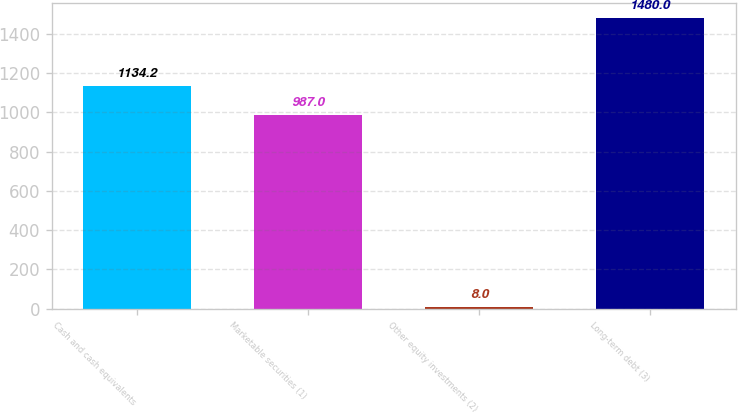<chart> <loc_0><loc_0><loc_500><loc_500><bar_chart><fcel>Cash and cash equivalents<fcel>Marketable securities (1)<fcel>Other equity investments (2)<fcel>Long-term debt (3)<nl><fcel>1134.2<fcel>987<fcel>8<fcel>1480<nl></chart> 